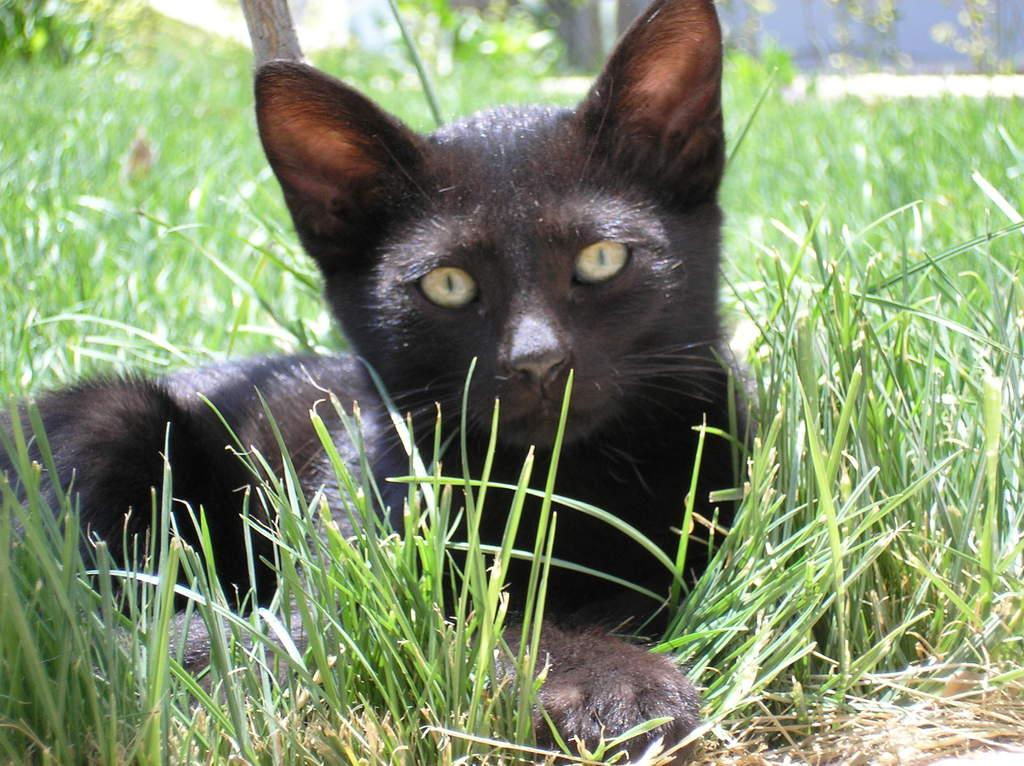What type of animal is in the image? There is a black cat in the image. Where is the black cat located? The black cat is sitting in the grass. What type of slope can be seen in the image? There is no slope present in the image; it features a black cat sitting in the grass. Can you see any ducks or arguments happening in the image? No, there are no ducks or arguments depicted in the image. 